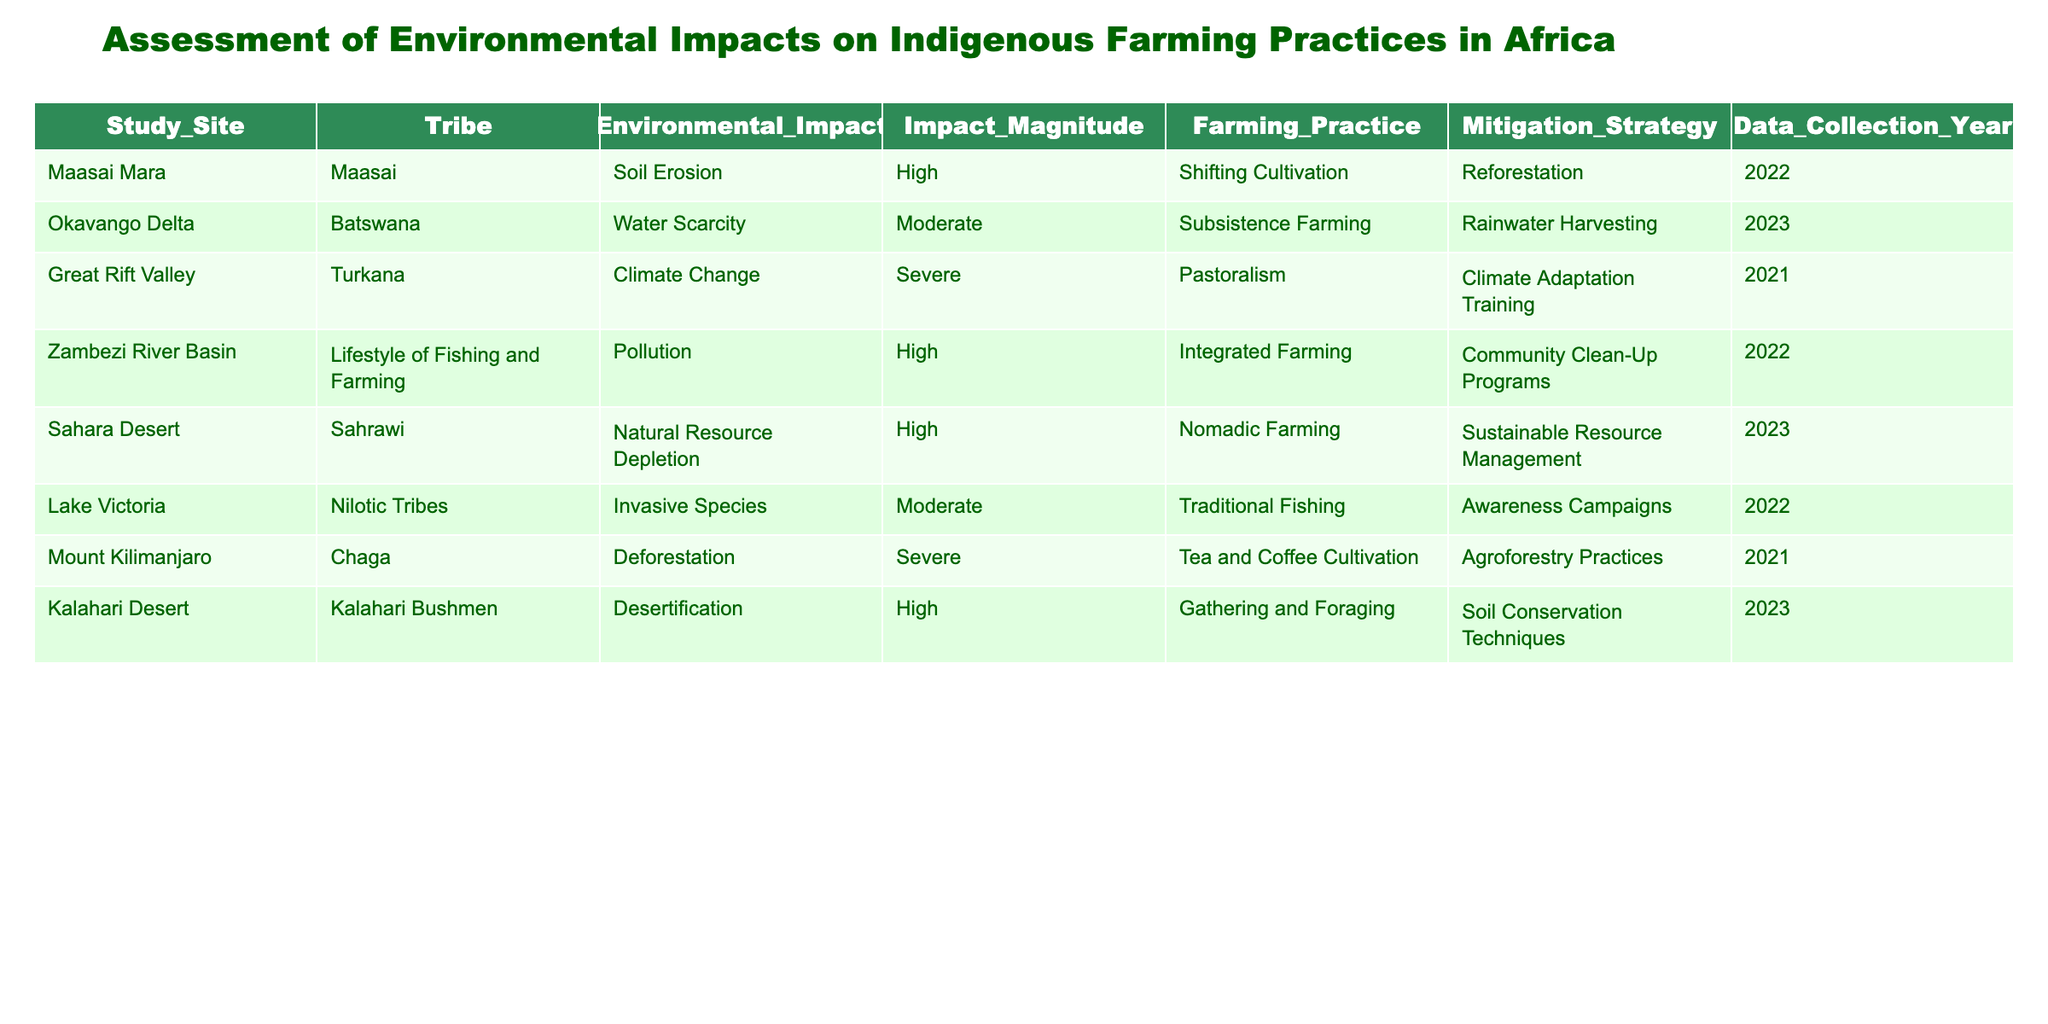What is the environmental impact associated with the Maasai tribe? The table shows that the environmental impact attributed to the Maasai tribe at the Maasai Mara study site is "Soil Erosion."
Answer: Soil Erosion What is the mitigation strategy implemented for water scarcity in the Okavango Delta? According to the table, the mitigation strategy for addressing water scarcity in the Okavango Delta is "Rainwater Harvesting."
Answer: Rainwater Harvesting Which farming practice is affected by climate change in the Great Rift Valley? The table indicates that the farming practice impacted by climate change in the Great Rift Valley is "Pastoralism."
Answer: Pastoralism Is the impact magnitude of pollution in the Zambezi River Basin categorized as high? Yes, the table categorizes the magnitude of pollution in the Zambezi River Basin as "High."
Answer: Yes What is the average impact magnitude for the tribes practicing farming? The farming tribes listed in the table are the Batswana, Chaga, and Nilotic Tribes with impact magnitudes of Moderate, Severe, and Moderate respectively. Adding them gives 2 (Moderate) + 3 (Severe) + 2 (Moderate) equals 7, dividing by 3 gives an average impact magnitude of approximately 2.33.
Answer: Approximately 2.33 How many tribes are experiencing severe environmental impacts? The table identifies two tribes experiencing severe environmental impacts: the Turkana tribe with climate change and the Chaga tribe with deforestation. Therefore, the count is 2.
Answer: 2 Were any tribes affected by invasive species? Yes, the table shows the Nilotic Tribes at Lake Victoria are affected by "Invasive Species."
Answer: Yes Which study site has the highest impact magnitude due to natural resource depletion? The table lists the Sahara Desert occupied by the Sahrawi tribe as having a high magnitude of "Natural Resource Depletion."
Answer: Sahara Desert 